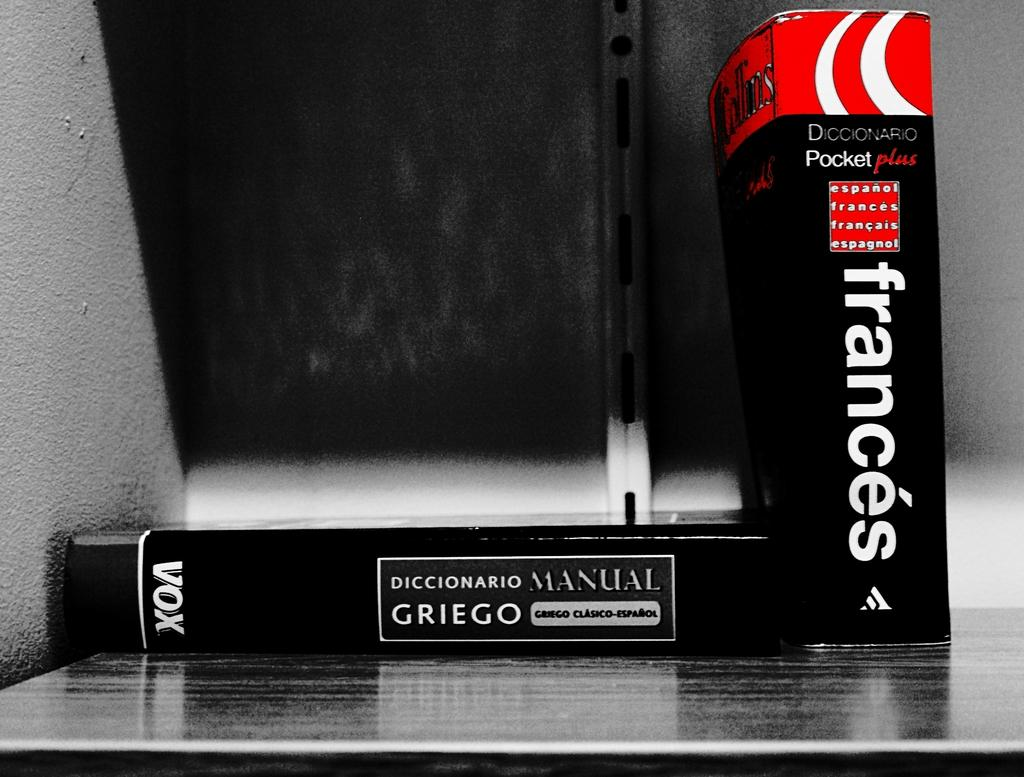<image>
Render a clear and concise summary of the photo. One dictionary on the right says frances and the other sasy Diccionario manual 